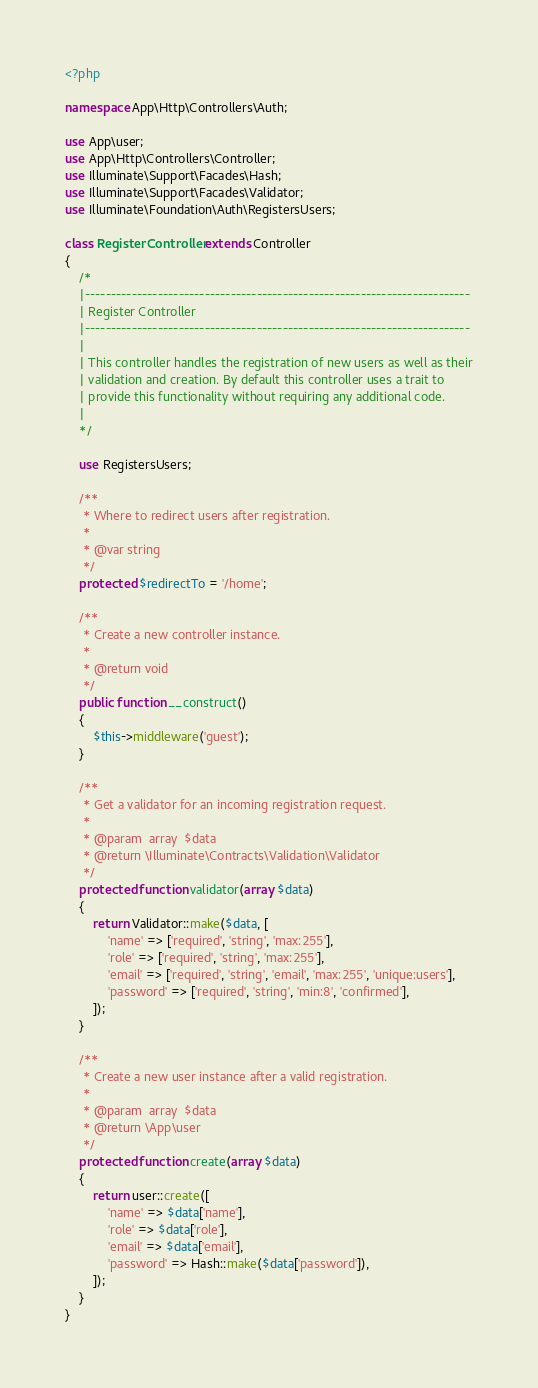Convert code to text. <code><loc_0><loc_0><loc_500><loc_500><_PHP_><?php

namespace App\Http\Controllers\Auth;

use App\user;
use App\Http\Controllers\Controller;
use Illuminate\Support\Facades\Hash;
use Illuminate\Support\Facades\Validator;
use Illuminate\Foundation\Auth\RegistersUsers;

class RegisterController extends Controller
{
    /*
    |--------------------------------------------------------------------------
    | Register Controller
    |--------------------------------------------------------------------------
    |
    | This controller handles the registration of new users as well as their
    | validation and creation. By default this controller uses a trait to
    | provide this functionality without requiring any additional code.
    |
    */

    use RegistersUsers;

    /**
     * Where to redirect users after registration.
     *
     * @var string
     */
    protected $redirectTo = '/home';

    /**
     * Create a new controller instance.
     *
     * @return void
     */
    public function __construct()
    {
        $this->middleware('guest');
    }

    /**
     * Get a validator for an incoming registration request.
     *
     * @param  array  $data
     * @return \Illuminate\Contracts\Validation\Validator
     */
    protected function validator(array $data)
    {
        return Validator::make($data, [
            'name' => ['required', 'string', 'max:255'],
            'role' => ['required', 'string', 'max:255'],
            'email' => ['required', 'string', 'email', 'max:255', 'unique:users'],
            'password' => ['required', 'string', 'min:8', 'confirmed'],
        ]);
    }

    /**
     * Create a new user instance after a valid registration.
     *
     * @param  array  $data
     * @return \App\user
     */
    protected function create(array $data)
    {
        return user::create([
            'name' => $data['name'],
            'role' => $data['role'],
            'email' => $data['email'],
            'password' => Hash::make($data['password']),
        ]);
    }
}
</code> 